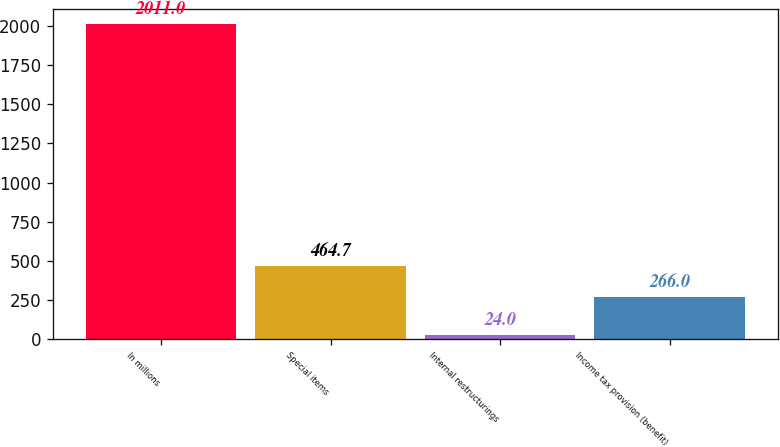Convert chart to OTSL. <chart><loc_0><loc_0><loc_500><loc_500><bar_chart><fcel>In millions<fcel>Special items<fcel>Internal restructurings<fcel>Income tax provision (benefit)<nl><fcel>2011<fcel>464.7<fcel>24<fcel>266<nl></chart> 